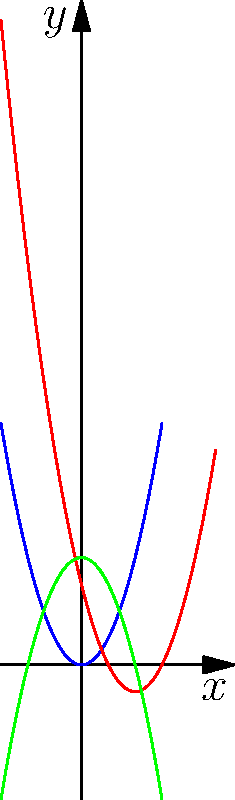In the given graph, three polynomial functions are plotted: $f(x)=x^2$ (blue), $g(x)=(x-2)^2-1$ (red), and $h(x)=-x^2+4$ (green). Which literary concept could be metaphorically represented by the transformation from $f(x)$ to $g(x)$, and why? To answer this question, let's analyze the transformation from $f(x)$ to $g(x)$:

1. $f(x)=x^2$ is the basic parabola centered at the origin.
2. $g(x)=(x-2)^2-1$ is a transformed version of $f(x)$.
3. The transformation involves:
   a) A horizontal shift of 2 units to the right ($(x-2)$)
   b) A vertical shift of 1 unit down ($-1$)

4. In literature, this transformation could metaphorically represent the concept of "displacement" or "alienation."

5. The horizontal shift (moving right) could symbolize a character's journey or progression through time.
6. The vertical shift (moving down) might represent a fall from grace or a descent into hardship.

7. This combination of movements reflects the idea of a character being removed from their original state (the origin in $f(x)$) and placed in a new, possibly challenging situation (the new position of the vertex in $g(x)$).

8. "Displacement" or "alienation" are common themes in classic Western literature, where characters often find themselves in unfamiliar situations or environments, forcing them to adapt and grow.
Answer: Displacement or alienation 